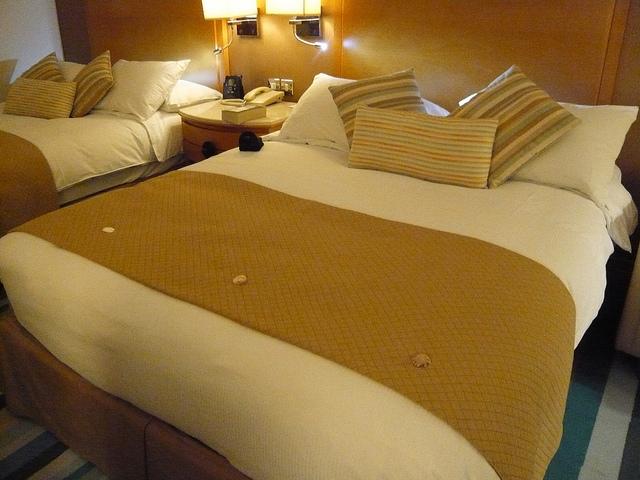Is the bed made?
Write a very short answer. Yes. How many pillows are visible?
Short answer required. 11. Is the light on?
Short answer required. Yes. 